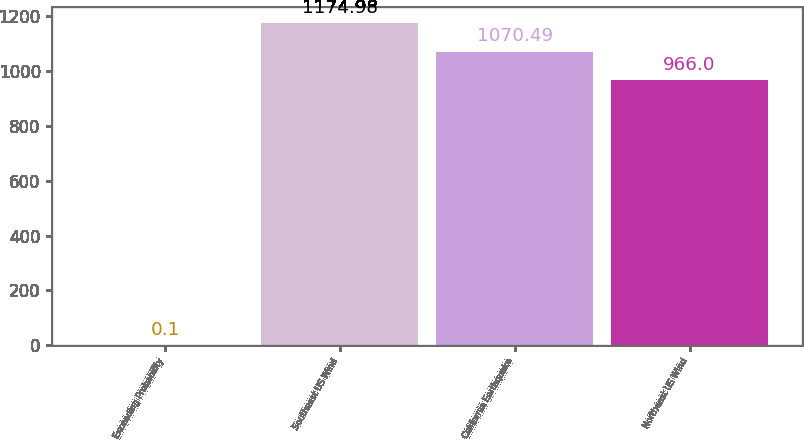Convert chart to OTSL. <chart><loc_0><loc_0><loc_500><loc_500><bar_chart><fcel>Exceeding Probability<fcel>Southeast US Wind<fcel>California Earthquake<fcel>Northeast US Wind<nl><fcel>0.1<fcel>1174.98<fcel>1070.49<fcel>966<nl></chart> 